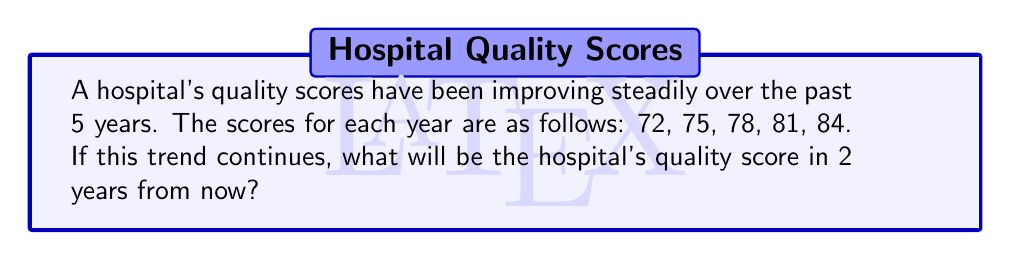Solve this math problem. To solve this problem, we need to identify the pattern in the sequence and extend it. Let's approach this step-by-step:

1. Identify the pattern:
   Let's calculate the difference between consecutive terms:
   75 - 72 = 3
   78 - 75 = 3
   81 - 78 = 3
   84 - 81 = 3

   We can see that the quality score increases by 3 points each year.

2. Recognize the arithmetic sequence:
   This is an arithmetic sequence with a common difference of 3.
   The general term of an arithmetic sequence is given by:
   $$a_n = a_1 + (n-1)d$$
   where $a_n$ is the nth term, $a_1$ is the first term, n is the position, and d is the common difference.

3. Calculate the next two terms:
   Current last term (5th year): 84
   6th year: 84 + 3 = 87
   7th year (2 years from now): 87 + 3 = 90

   Alternatively, we can use the general term formula:
   $$a_7 = 72 + (7-1)3 = 72 + 18 = 90$$

Therefore, in 2 years from now, the hospital's quality score will be 90.
Answer: 90 